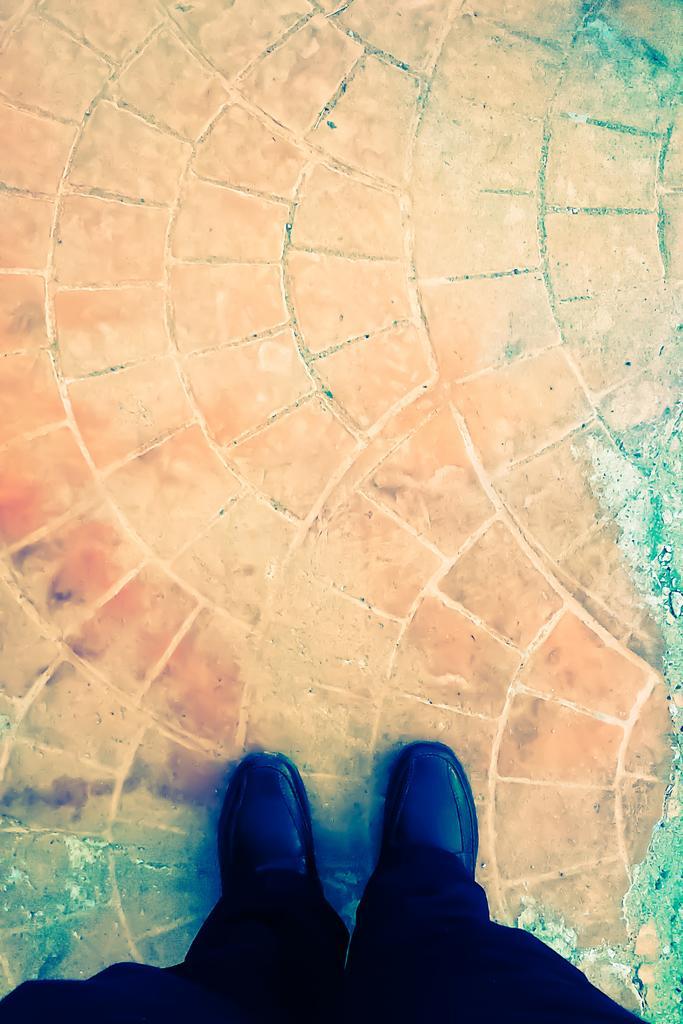Could you give a brief overview of what you see in this image? In the image there is a person standing in the front on the land, he is wearing black pants and black shoe. 